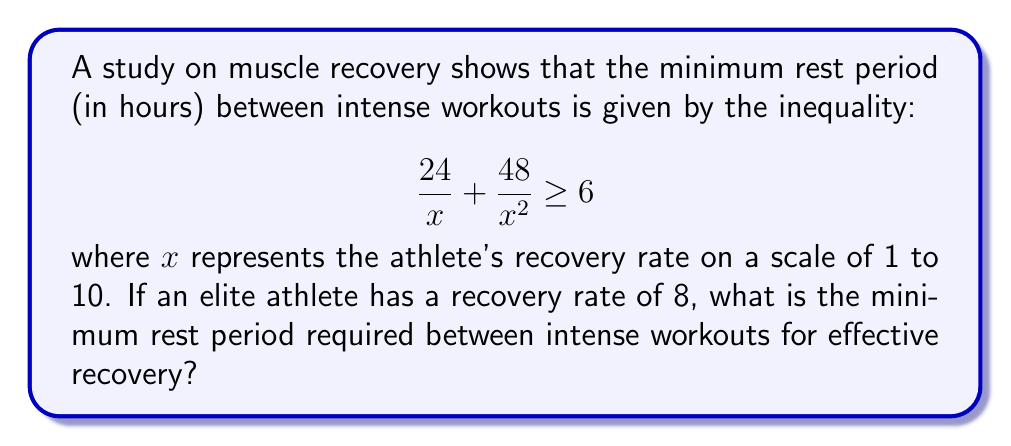Can you solve this math problem? 1) We start with the given inequality:
   $$ \frac{24}{x} + \frac{48}{x^2} \geq 6 $$

2) We know that $x = 8$ for our elite athlete. Let's substitute this:
   $$ \frac{24}{8} + \frac{48}{8^2} \geq 6 $$

3) Simplify the fractions:
   $$ 3 + \frac{48}{64} \geq 6 $$

4) Simplify further:
   $$ 3 + 0.75 \geq 6 $$

5) Calculate the left side:
   $$ 3.75 \geq 6 $$

6) This inequality is not satisfied, which means we need to find the actual minimum rest period that satisfies the original inequality.

7) Let's call the minimum rest period $y$. We can set up the equation:
   $$ \frac{24y}{8} + \frac{48y}{8^2} = 6 $$

8) Simplify:
   $$ 3y + 0.75y = 6 $$

9) Combine like terms:
   $$ 3.75y = 6 $$

10) Solve for $y$:
    $$ y = \frac{6}{3.75} = 1.6 $$

Therefore, the minimum rest period is 1.6 hours.
Answer: 1.6 hours 